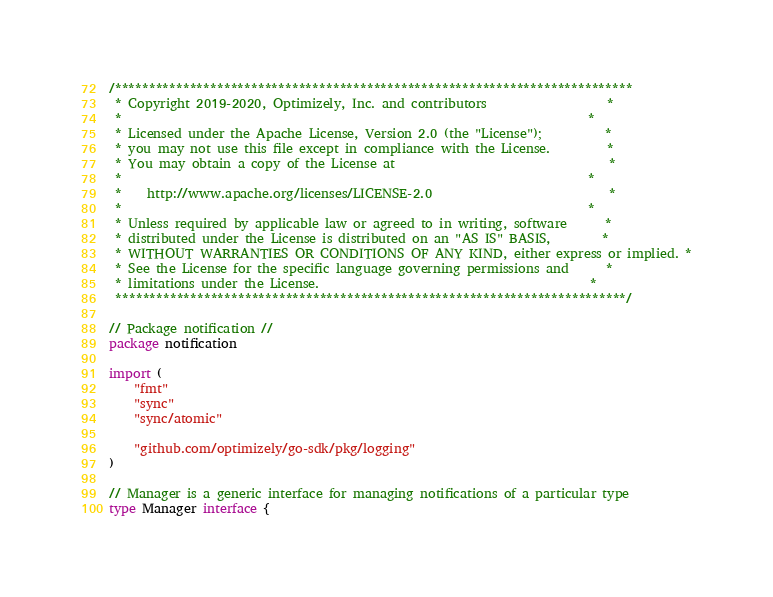<code> <loc_0><loc_0><loc_500><loc_500><_Go_>/****************************************************************************
 * Copyright 2019-2020, Optimizely, Inc. and contributors                   *
 *                                                                          *
 * Licensed under the Apache License, Version 2.0 (the "License");          *
 * you may not use this file except in compliance with the License.         *
 * You may obtain a copy of the License at                                  *
 *                                                                          *
 *    http://www.apache.org/licenses/LICENSE-2.0                            *
 *                                                                          *
 * Unless required by applicable law or agreed to in writing, software      *
 * distributed under the License is distributed on an "AS IS" BASIS,        *
 * WITHOUT WARRANTIES OR CONDITIONS OF ANY KIND, either express or implied. *
 * See the License for the specific language governing permissions and      *
 * limitations under the License.                                           *
 ***************************************************************************/

// Package notification //
package notification

import (
	"fmt"
	"sync"
	"sync/atomic"

	"github.com/optimizely/go-sdk/pkg/logging"
)

// Manager is a generic interface for managing notifications of a particular type
type Manager interface {</code> 